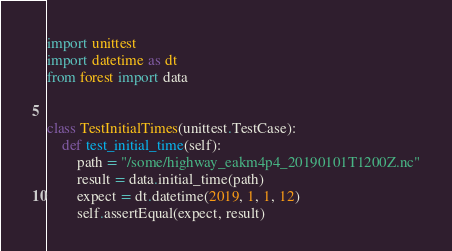Convert code to text. <code><loc_0><loc_0><loc_500><loc_500><_Python_>import unittest
import datetime as dt
from forest import data


class TestInitialTimes(unittest.TestCase):
    def test_initial_time(self):
        path = "/some/highway_eakm4p4_20190101T1200Z.nc"
        result = data.initial_time(path)
        expect = dt.datetime(2019, 1, 1, 12)
        self.assertEqual(expect, result)
</code> 